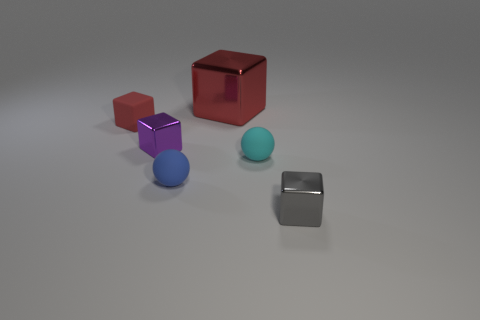How many red cubes must be subtracted to get 1 red cubes? 1 Subtract all small cubes. How many cubes are left? 1 Subtract 1 spheres. How many spheres are left? 1 Add 5 tiny matte things. How many tiny matte things are left? 8 Add 3 purple things. How many purple things exist? 4 Add 2 tiny yellow metallic cylinders. How many objects exist? 8 Subtract all blue spheres. How many spheres are left? 1 Subtract 0 brown spheres. How many objects are left? 6 Subtract all spheres. How many objects are left? 4 Subtract all gray blocks. Subtract all gray cylinders. How many blocks are left? 3 